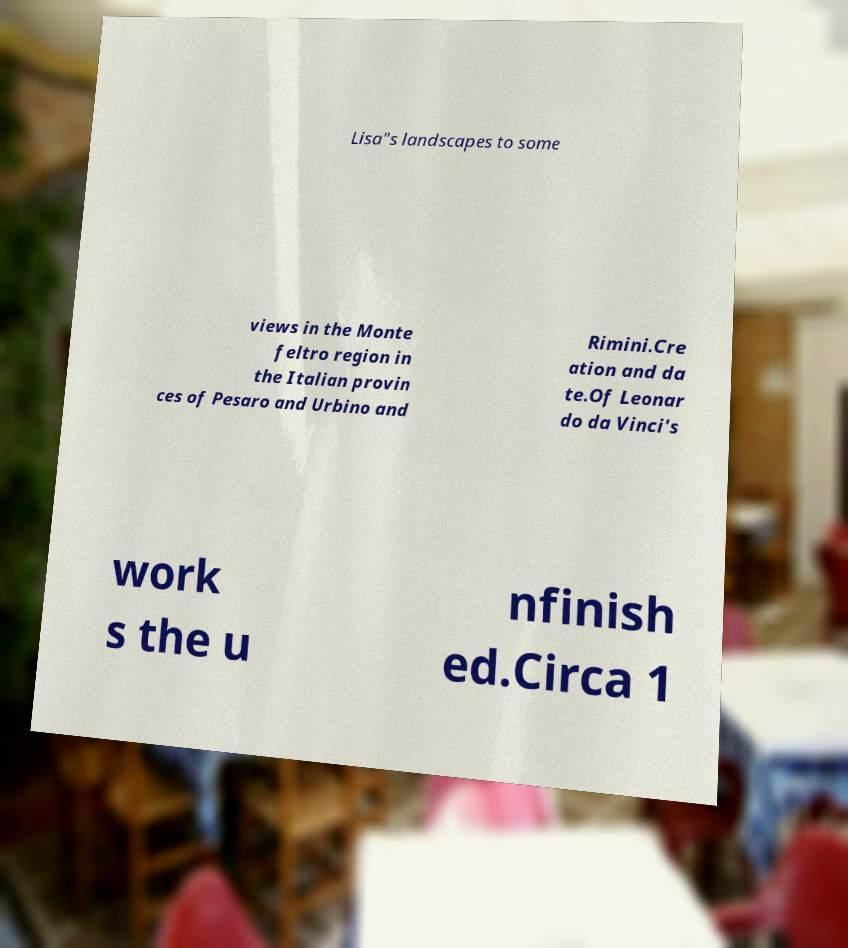Could you extract and type out the text from this image? Lisa"s landscapes to some views in the Monte feltro region in the Italian provin ces of Pesaro and Urbino and Rimini.Cre ation and da te.Of Leonar do da Vinci's work s the u nfinish ed.Circa 1 